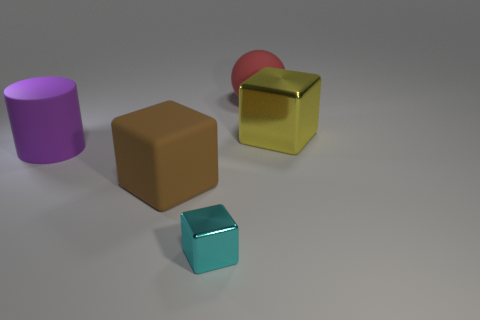The cylinder that is made of the same material as the red sphere is what color?
Give a very brief answer. Purple. Are the big brown block and the small cyan cube in front of the large brown block made of the same material?
Provide a short and direct response. No. What color is the big matte ball?
Give a very brief answer. Red. The cylinder that is made of the same material as the big sphere is what size?
Your answer should be compact. Large. There is a metal thing behind the large purple matte thing behind the small cube; what number of cubes are in front of it?
Provide a succinct answer. 2. Do the small object and the metallic block behind the brown cube have the same color?
Your response must be concise. No. The block left of the metallic thing that is left of the shiny block behind the large purple object is made of what material?
Offer a terse response. Rubber. There is a big rubber object that is on the right side of the cyan metal block; does it have the same shape as the purple thing?
Provide a short and direct response. No. There is a large object that is on the left side of the big rubber cube; what material is it?
Provide a succinct answer. Rubber. How many rubber things are small cyan cubes or blocks?
Offer a terse response. 1. 